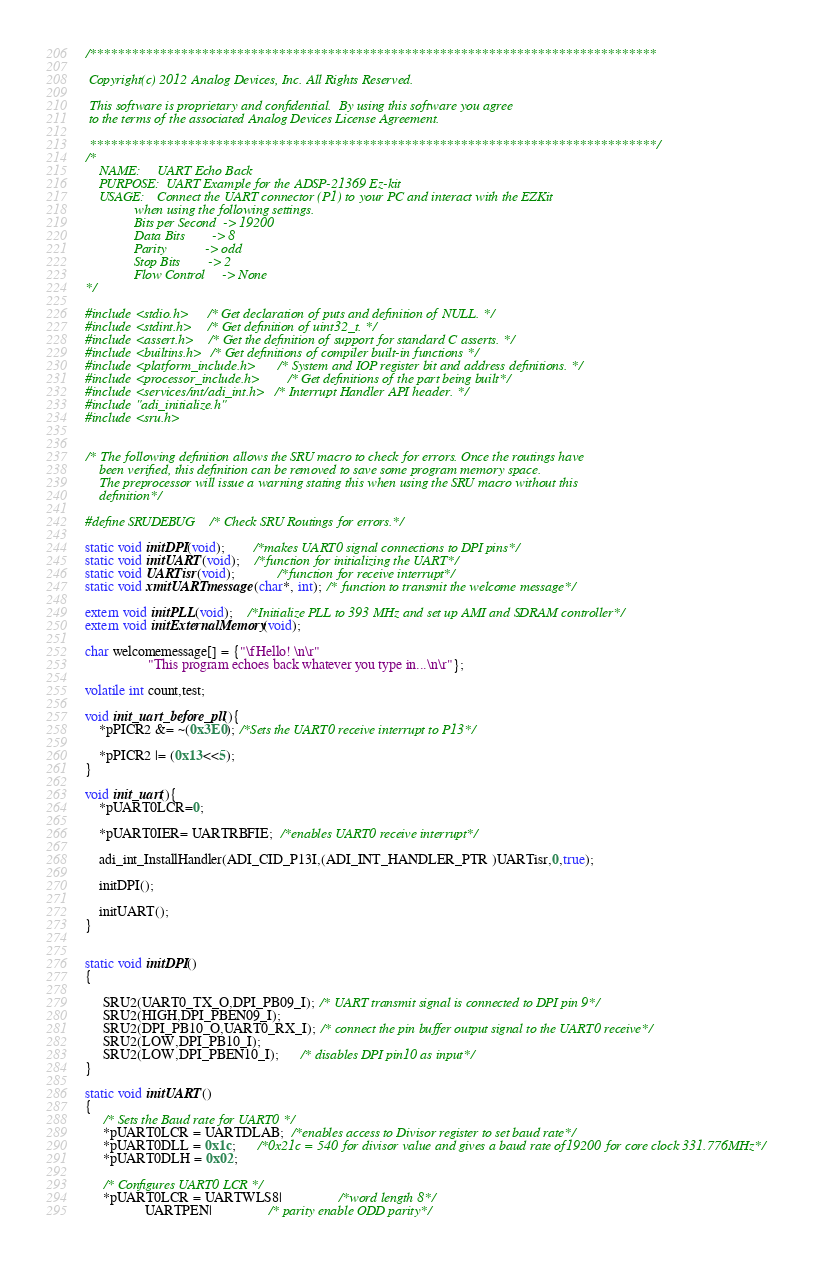Convert code to text. <code><loc_0><loc_0><loc_500><loc_500><_C_>/*********************************************************************************

 Copyright(c) 2012 Analog Devices, Inc. All Rights Reserved.

 This software is proprietary and confidential.  By using this software you agree
 to the terms of the associated Analog Devices License Agreement.

 *********************************************************************************/
/*
	NAME:     UART Echo Back
	PURPOSE:  UART Example for the ADSP-21369 Ez-kit
	USAGE:    Connect the UART connector (P1) to your PC and interact with the EZKit
          	  when using the following settings.
          	  Bits per Second  -> 19200
          	  Data Bits        -> 8
          	  Parity           -> odd
          	  Stop Bits        -> 2
         	  Flow Control     -> None
*/

#include <stdio.h>     /* Get declaration of puts and definition of NULL. */
#include <stdint.h>    /* Get definition of uint32_t. */
#include <assert.h>    /* Get the definition of support for standard C asserts. */
#include <builtins.h>  /* Get definitions of compiler built-in functions */
#include <platform_include.h>      /* System and IOP register bit and address definitions. */
#include <processor_include.h>	   /* Get definitions of the part being built*/
#include <services/int/adi_int.h>  /* Interrupt Handler API header. */
#include "adi_initialize.h"
#include <sru.h>


/* The following definition allows the SRU macro to check for errors. Once the routings have
	been verified, this definition can be removed to save some program memory space.
 	The preprocessor will issue a warning stating this when using the SRU macro without this
    definition*/

#define SRUDEBUG  /* Check SRU Routings for errors.*/

static void initDPI(void);		/*makes UART0 signal connections to DPI pins*/
static void initUART(void);	/*function for initializing the UART*/
static void UARTisr(void);			/*function for receive interrupt*/
static void xmitUARTmessage(char*, int); /* function to transmit the welcome message*/

extern void initPLL(void);    /*Initialize PLL to 393 MHz and set up AMI and SDRAM controller*/
extern void initExternalMemory(void);

char welcomemessage[] = {"\fHello! \n\r"
                  "This program echoes back whatever you type in...\n\r"};

volatile int count,test;

void init_uart_before_pll(){
	*pPICR2 &= ~(0x3E0); /*Sets the UART0 receive interrupt to P13*/

	*pPICR2 |= (0x13<<5);
}

void init_uart(){
	*pUART0LCR=0;

    *pUART0IER= UARTRBFIE;  /*enables UART0 receive interrupt*/

    adi_int_InstallHandler(ADI_CID_P13I,(ADI_INT_HANDLER_PTR )UARTisr,0,true);

    initDPI();

	initUART();
}


static void initDPI()
{

     SRU2(UART0_TX_O,DPI_PB09_I); /* UART transmit signal is connected to DPI pin 9*/
     SRU2(HIGH,DPI_PBEN09_I);
     SRU2(DPI_PB10_O,UART0_RX_I); /* connect the pin buffer output signal to the UART0 receive*/
     SRU2(LOW,DPI_PB10_I);
     SRU2(LOW,DPI_PBEN10_I);      /* disables DPI pin10 as input*/
}

static void initUART()
{
	 /* Sets the Baud rate for UART0 */
	 *pUART0LCR = UARTDLAB;  /*enables access to Divisor register to set baud rate*/
	 *pUART0DLL = 0x1c;      /*0x21c = 540 for divisor value and gives a baud rate of19200 for core clock 331.776MHz*/
     *pUART0DLH = 0x02;

     /* Configures UART0 LCR */
     *pUART0LCR = UARTWLS8| 				/*word length 8*/
                 UARTPEN| 				/* parity enable ODD parity*/</code> 